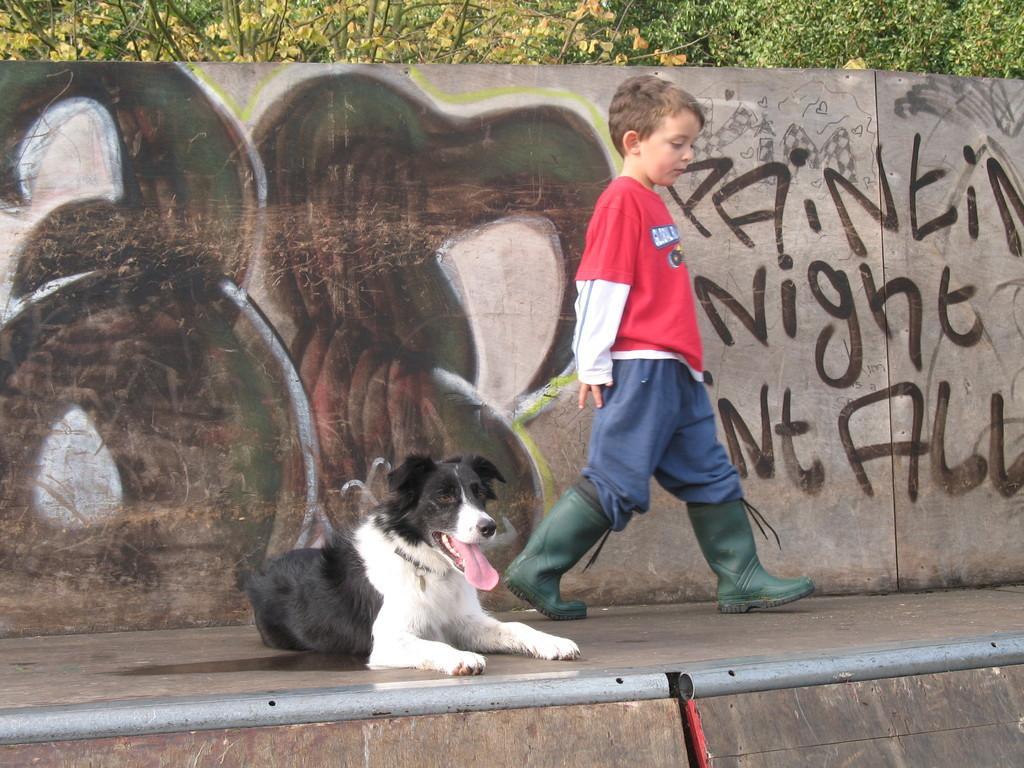Can you describe this image briefly? In this image there is a footpath on that footpath a dog is laying and a boy is walking, in the background there is a wall, on that wall there is painting and text and there are trees. 